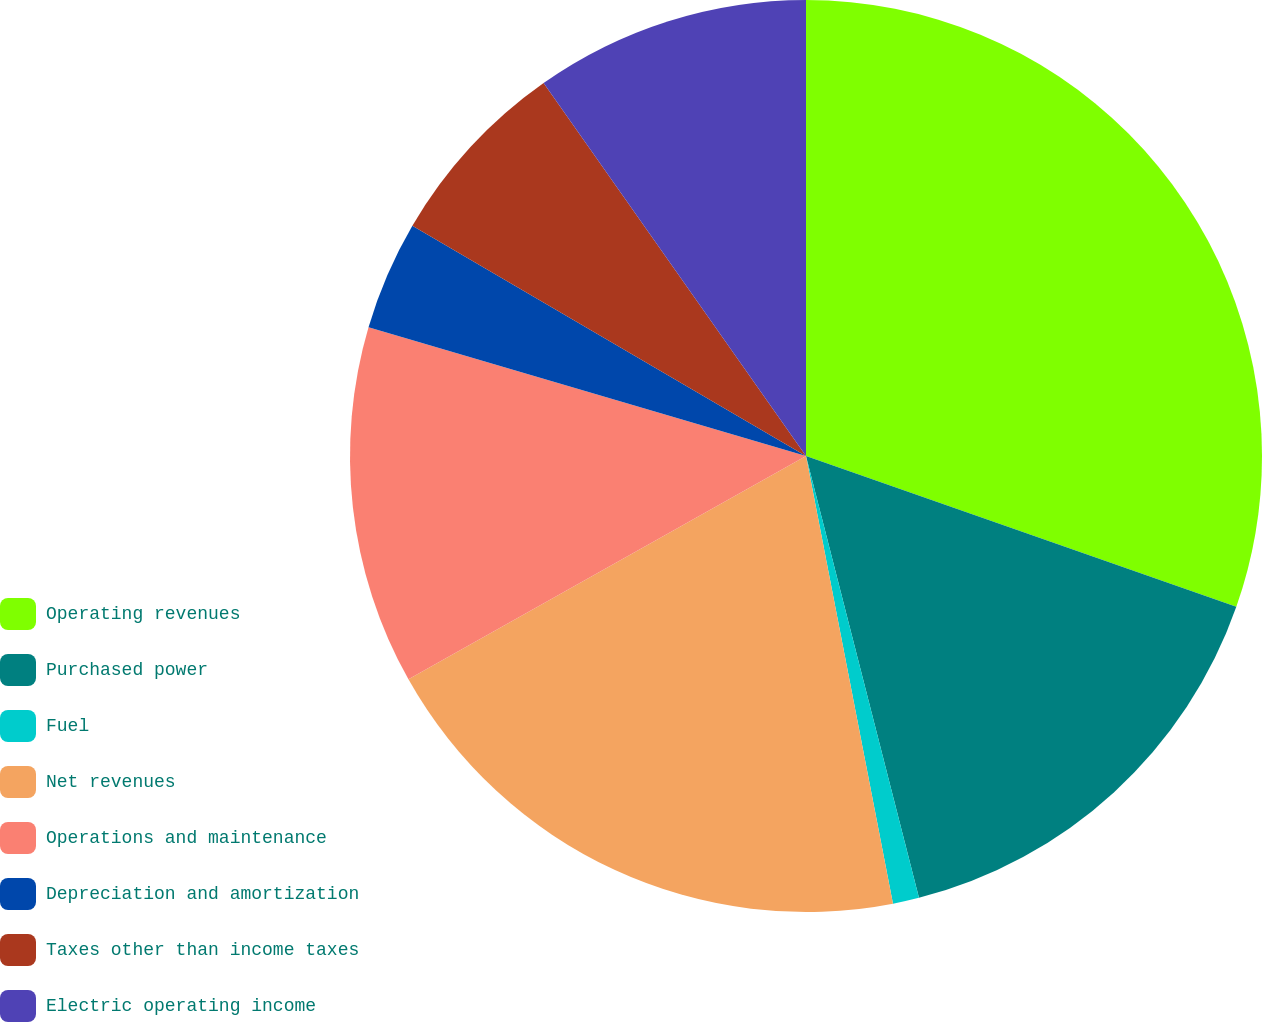<chart> <loc_0><loc_0><loc_500><loc_500><pie_chart><fcel>Operating revenues<fcel>Purchased power<fcel>Fuel<fcel>Net revenues<fcel>Operations and maintenance<fcel>Depreciation and amortization<fcel>Taxes other than income taxes<fcel>Electric operating income<nl><fcel>30.37%<fcel>15.65%<fcel>0.93%<fcel>19.91%<fcel>12.7%<fcel>3.87%<fcel>6.82%<fcel>9.76%<nl></chart> 